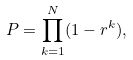<formula> <loc_0><loc_0><loc_500><loc_500>P = \prod _ { k = 1 } ^ { N } ( 1 - r ^ { k } ) ,</formula> 